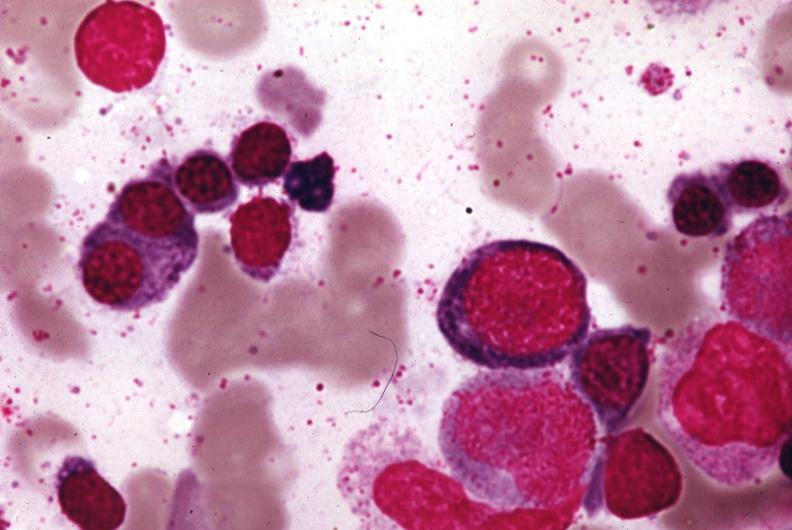what stain?
Answer the question using a single word or phrase. Wrights 